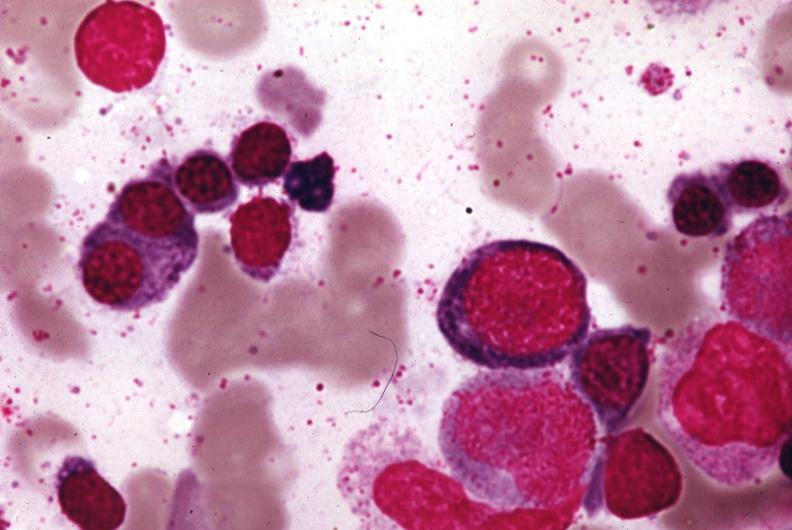what stain?
Answer the question using a single word or phrase. Wrights 